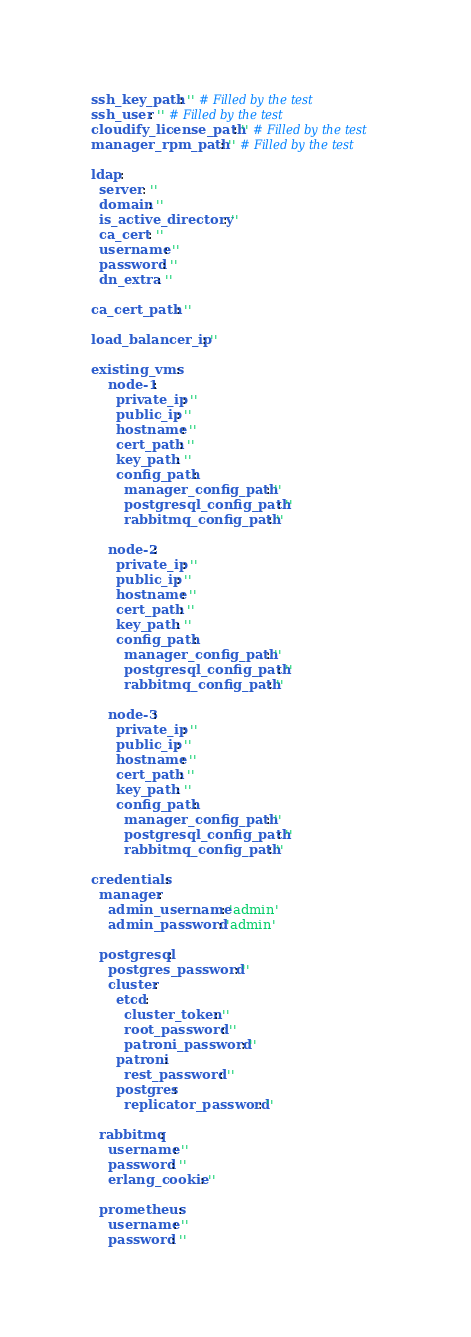<code> <loc_0><loc_0><loc_500><loc_500><_YAML_>ssh_key_path: '' # Filled by the test
ssh_user: '' # Filled by the test
cloudify_license_path: '' # Filled by the test
manager_rpm_path: '' # Filled by the test

ldap:
  server: ''
  domain: ''
  is_active_directory: ''
  ca_cert: ''
  username: ''
  password: ''
  dn_extra: ''

ca_cert_path: ''

load_balancer_ip: ''

existing_vms:
    node-1:
      private_ip: ''
      public_ip: ''
      hostname: ''
      cert_path: ''
      key_path: ''
      config_path:
        manager_config_path: ''
        postgresql_config_path: ''
        rabbitmq_config_path: ''

    node-2:
      private_ip: ''
      public_ip: ''
      hostname: ''
      cert_path: ''
      key_path: ''
      config_path:
        manager_config_path: ''
        postgresql_config_path: ''
        rabbitmq_config_path: ''

    node-3:
      private_ip: ''
      public_ip: ''
      hostname: ''
      cert_path: ''
      key_path: ''
      config_path:
        manager_config_path: ''
        postgresql_config_path: ''
        rabbitmq_config_path: ''

credentials:
  manager:
    admin_username: 'admin'
    admin_password: 'admin'

  postgresql:
    postgres_password: ''
    cluster:
      etcd:
        cluster_token: ''
        root_password: ''
        patroni_password: ''
      patroni:
        rest_password: ''
      postgres:
        replicator_password: ''

  rabbitmq:
    username: ''
    password: ''
    erlang_cookie: ''

  prometheus:
    username: ''
    password: ''
</code> 